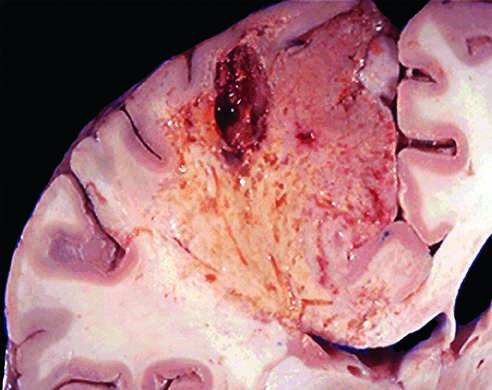what shows dissolution of the tissue?
Answer the question using a single word or phrase. An infarct in the brain 